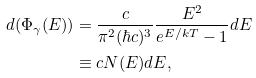<formula> <loc_0><loc_0><loc_500><loc_500>d ( \Phi _ { \gamma } ( E ) ) = & \ \frac { c } { \pi ^ { 2 } ( \hbar { c } ) ^ { 3 } } \frac { E ^ { 2 } } { e ^ { E / k T } - 1 } d E \\ \equiv & \ c N ( E ) d E ,</formula> 